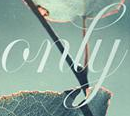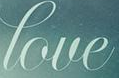What text appears in these images from left to right, separated by a semicolon? only; love 